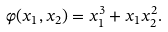Convert formula to latex. <formula><loc_0><loc_0><loc_500><loc_500>\varphi ( x _ { 1 } , x _ { 2 } ) = x _ { 1 } ^ { 3 } + x _ { 1 } x _ { 2 } ^ { 2 } .</formula> 